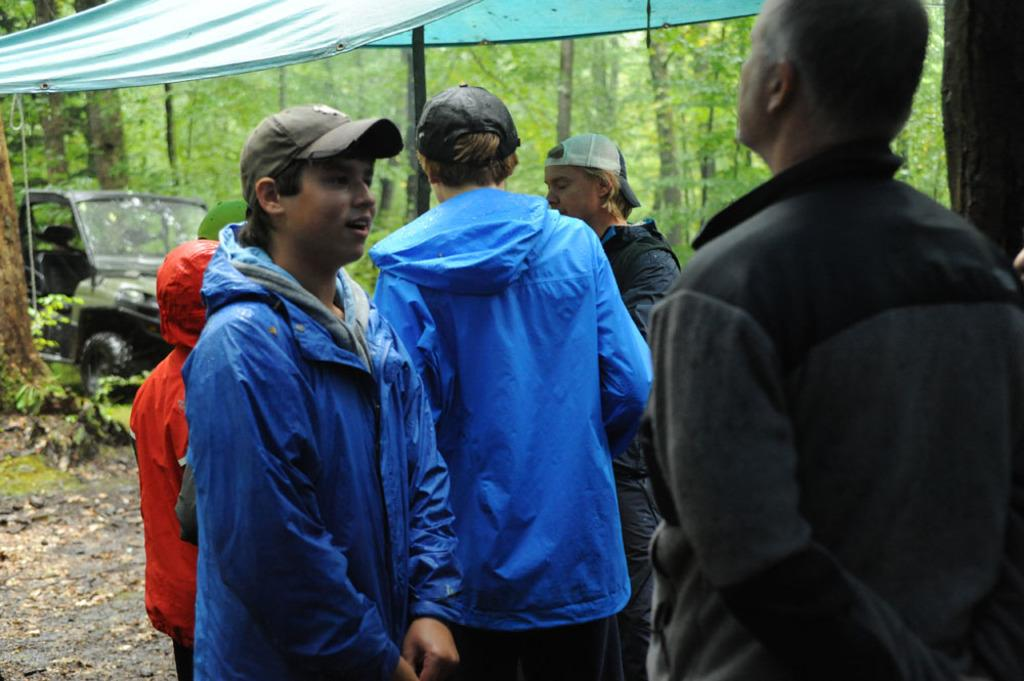What are the people in the image doing? There is a group of people on the ground in the image. What else can be seen in the image besides the people? There is a vehicle and a tent in the image. What is visible in the background of the image? There are trees visible in the background of the image. What channel is the people watching in the image? There is no indication of a television or any channel in the image. What is the name of the person sitting next to the tent? The image does not provide any names or identities of the people in the image. 